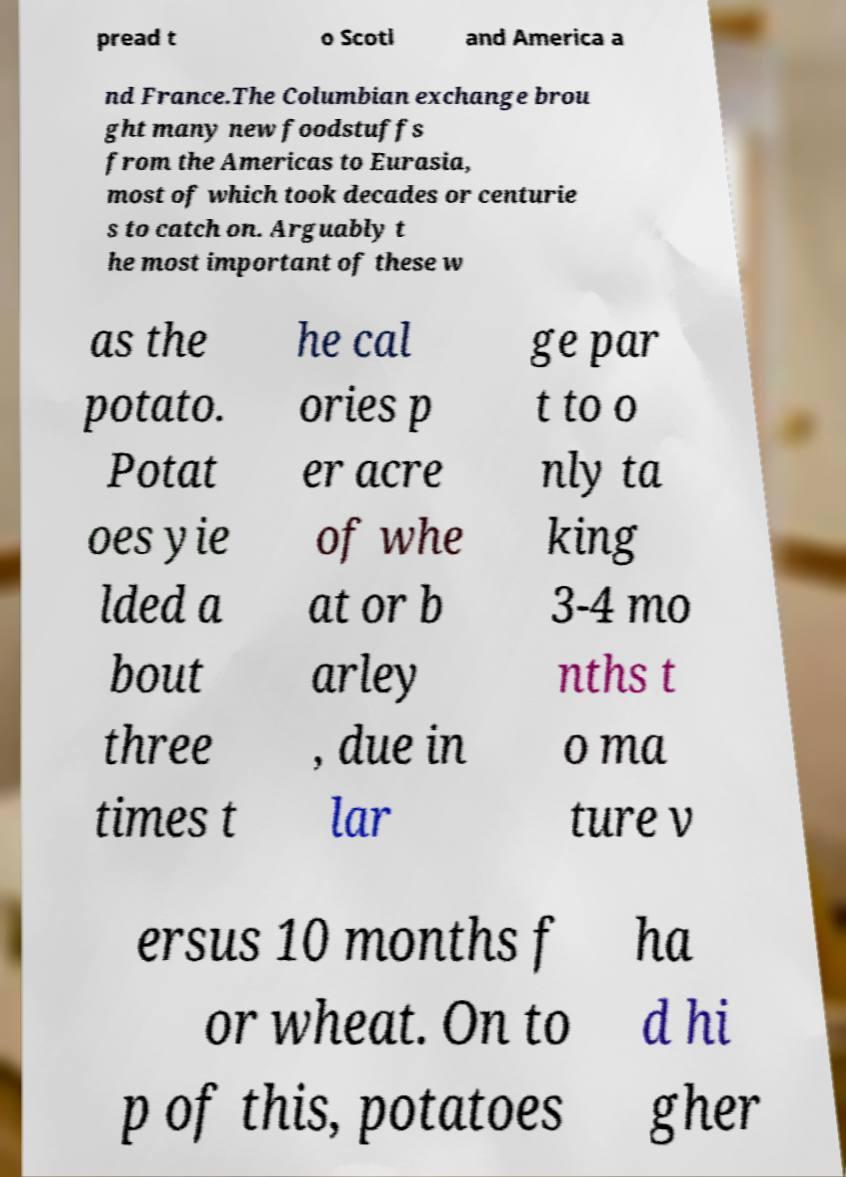There's text embedded in this image that I need extracted. Can you transcribe it verbatim? pread t o Scotl and America a nd France.The Columbian exchange brou ght many new foodstuffs from the Americas to Eurasia, most of which took decades or centurie s to catch on. Arguably t he most important of these w as the potato. Potat oes yie lded a bout three times t he cal ories p er acre of whe at or b arley , due in lar ge par t to o nly ta king 3-4 mo nths t o ma ture v ersus 10 months f or wheat. On to p of this, potatoes ha d hi gher 